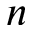<formula> <loc_0><loc_0><loc_500><loc_500>n</formula> 